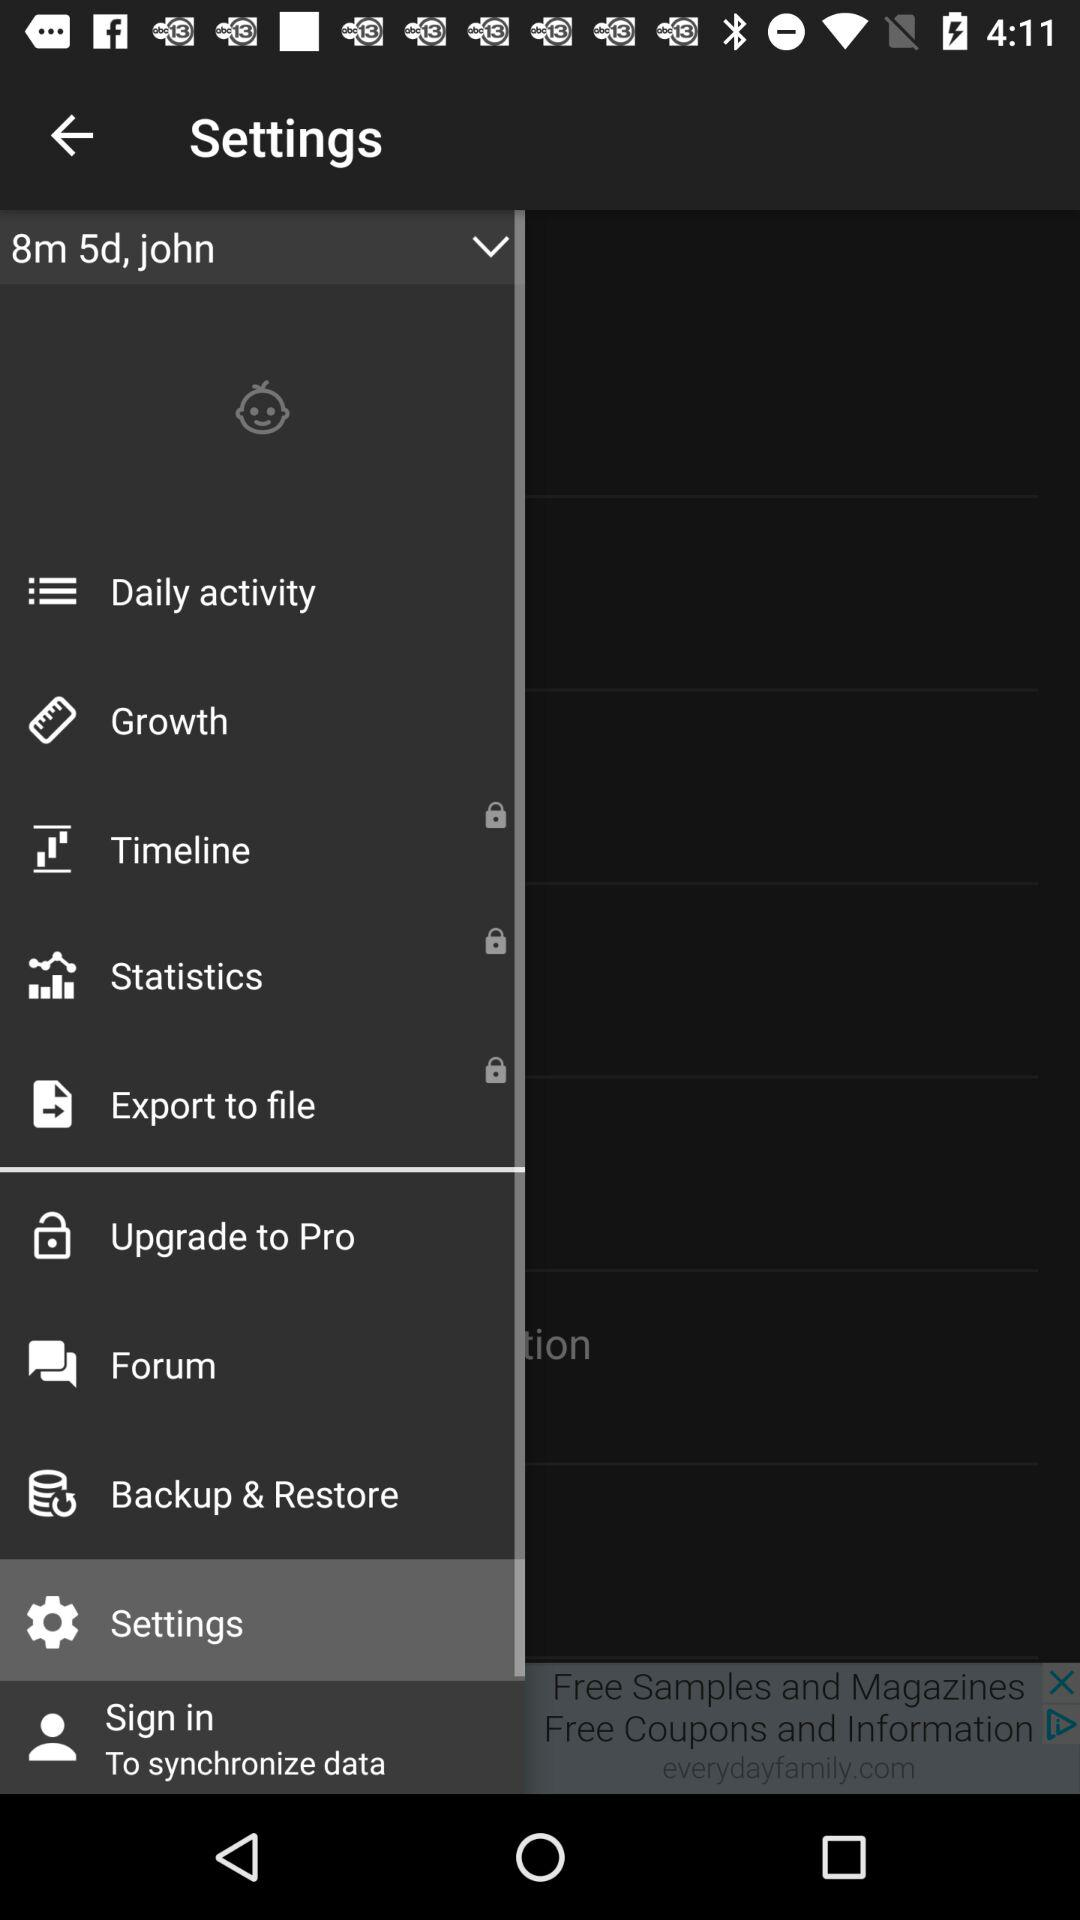Which options are locked? The locked options are "Timeline", "Statistics", and "Export to file". 